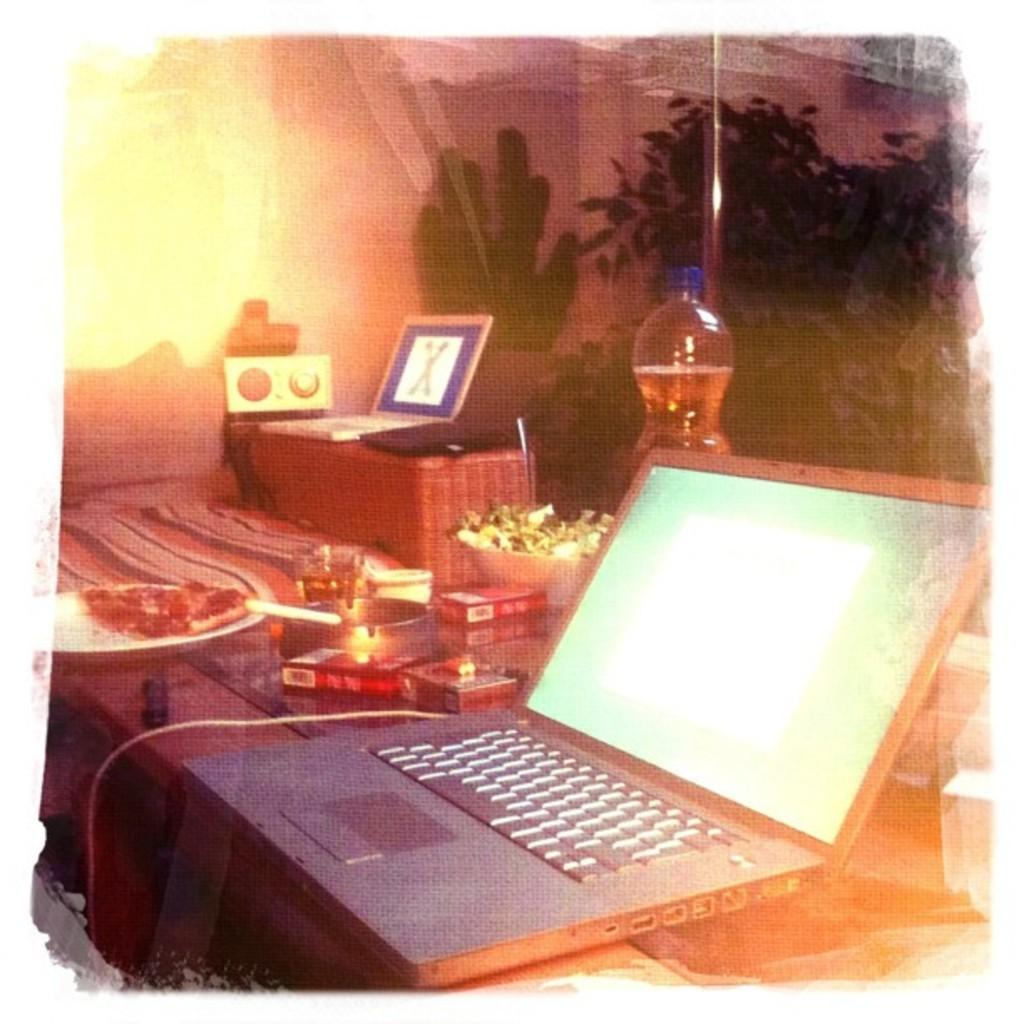What electronic device is on the table in the image? There is a laptop on the table in the image. What type of food is on the table? There is a plate of food on the table. What else can be seen on the table besides the laptop and food? There is a bottle and other unspecified things on the table. What is present in front of the table? Plants are present in front of the table. What is the taste of the laptop in the image? The laptop does not have a taste, as it is an electronic device and not a food item. Who is the owner of the laptop in the image? The image does not provide information about the owner of the laptop. 